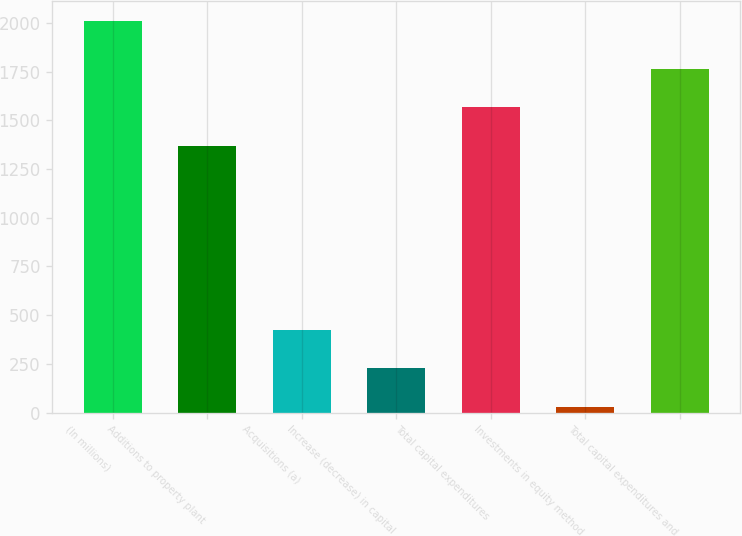Convert chart to OTSL. <chart><loc_0><loc_0><loc_500><loc_500><bar_chart><fcel>(In millions)<fcel>Additions to property plant<fcel>Acquisitions (a)<fcel>Increase (decrease) in capital<fcel>Total capital expenditures<fcel>Investments in equity method<fcel>Total capital expenditures and<nl><fcel>2012<fcel>1369<fcel>424.8<fcel>226.4<fcel>1567.4<fcel>28<fcel>1765.8<nl></chart> 